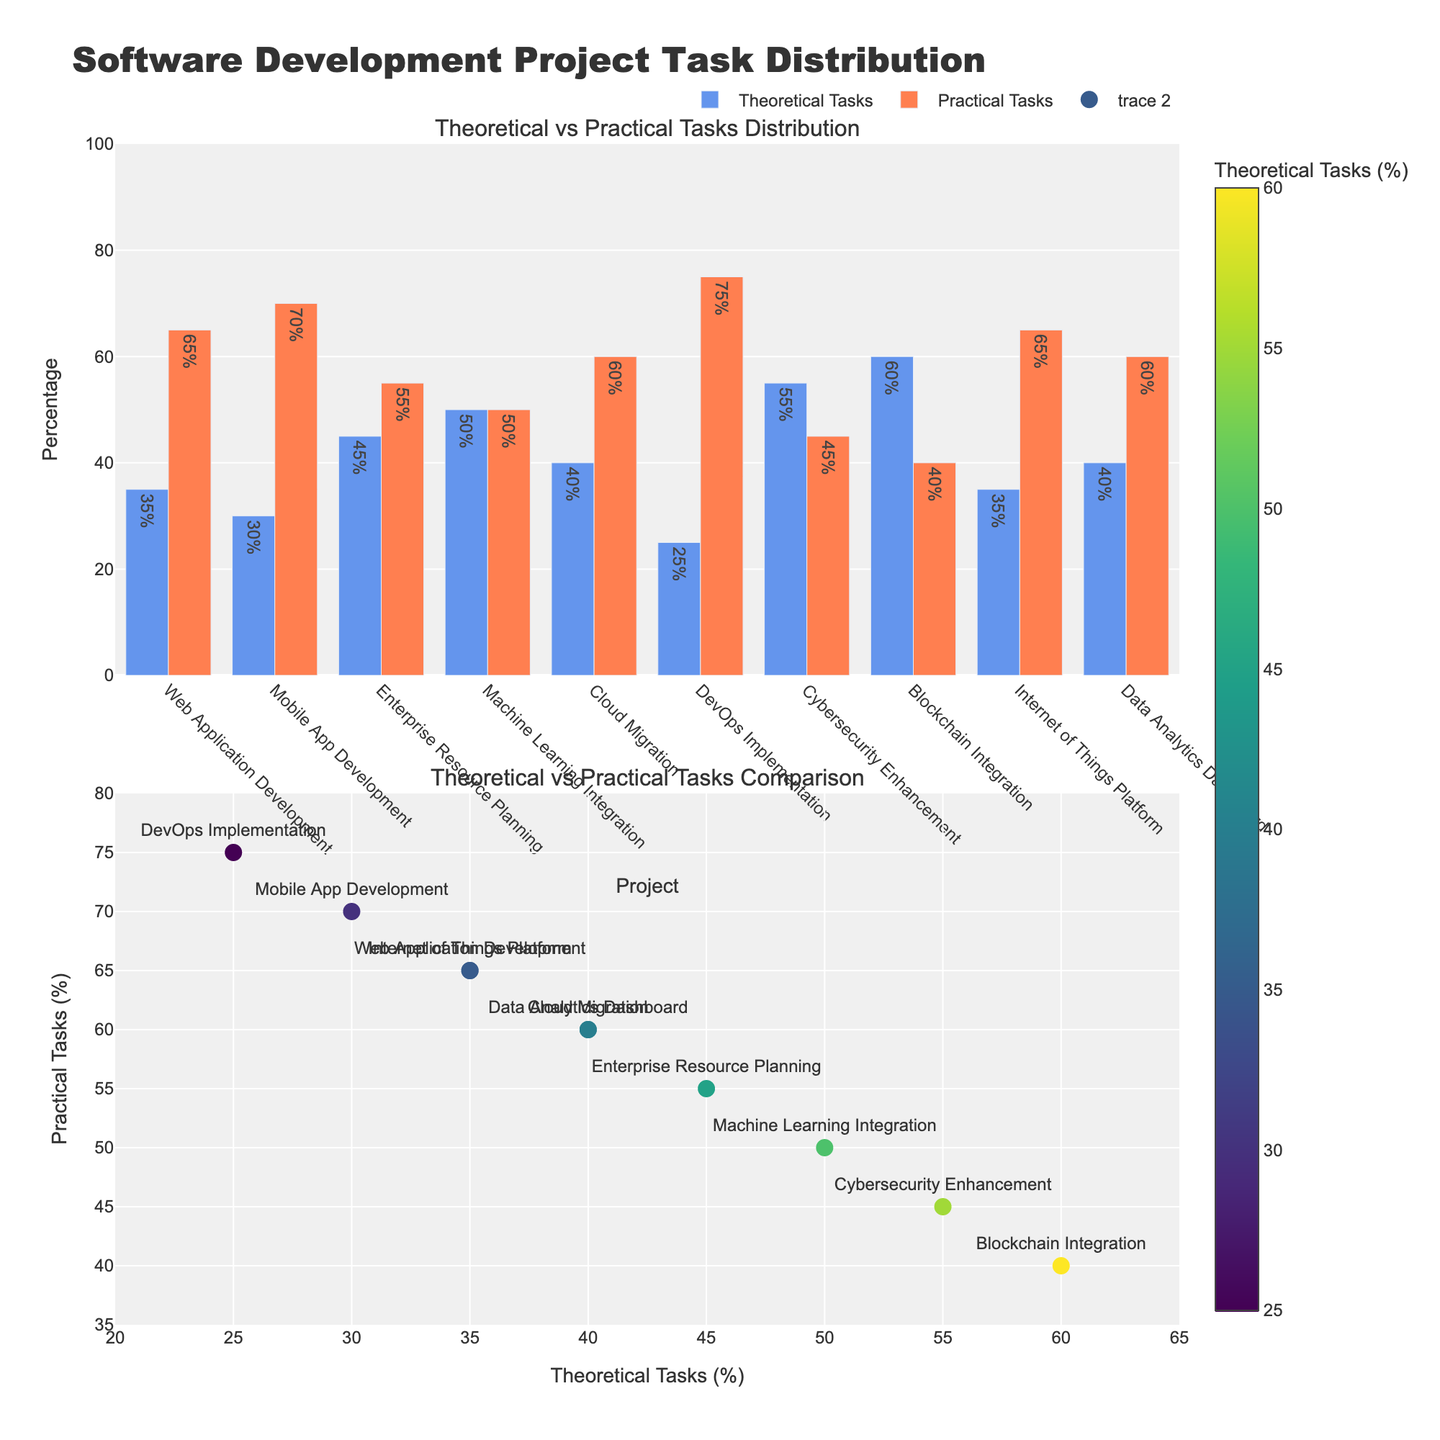What is the title of the figure? The title is displayed at the top of the figure. It reads "Software Development Project Task Distribution".
Answer: Software Development Project Task Distribution What are the two subplot titles? The subplot titles are located at the top of each subplot. They are "Theoretical vs Practical Tasks Distribution" for the bar chart and "Theoretical vs Practical Tasks Comparison" for the scatter plot.
Answer: Theoretical vs Practical Tasks Distribution, Theoretical vs Practical Tasks Comparison Which project has the highest percentage of theoretical tasks? Examine the heights of the blue bars in the bar chart. The project with the highest blue bar is "Blockchain Integration" at 60%.
Answer: Blockchain Integration How many projects have an equal distribution of theoretical and practical tasks? Refer to the scatter plot and identify the point where x equals y. Only "Machine Learning Integration" has this equal distribution with 50% theoretical and 50% practical tasks.
Answer: One Which project has the highest percentage of practical tasks? Look at the heights of the orange bars in the bar chart. The project with the highest orange bar is "DevOps Implementation" at 75%.
Answer: DevOps Implementation What is the percentage difference between theoretical and practical tasks in "Web Application Development"? In the bar chart, "Web Application Development" has 35% theoretical and 65% practical tasks. The difference is 65% - 35% = 30%.
Answer: 30% Compare the theoretical tasks of "Cybersecurity Enhancement" and "Blockchain Integration". Which one is higher? Check the heights of the respective blue bars. "Blockchain Integration" has a higher percentage of theoretical tasks (60%) compared to "Cybersecurity Enhancement" (55%).
Answer: Blockchain Integration For "Internet of Things Platform," what is the percentage of practical tasks? Refer to the bar chart for the "Internet of Things Platform". The orange bar represents practical tasks, which is 65%.
Answer: 65% What color is used to represent practical tasks in the bar chart? Practical tasks are represented by the orange bars, visible in the bar chart.
Answer: Orange Which project has the least theoretical tasks, and what is the percentage? By examining the bar chart, "DevOps Implementation" has the least theoretical tasks, which is 25%.
Answer: DevOps Implementation 